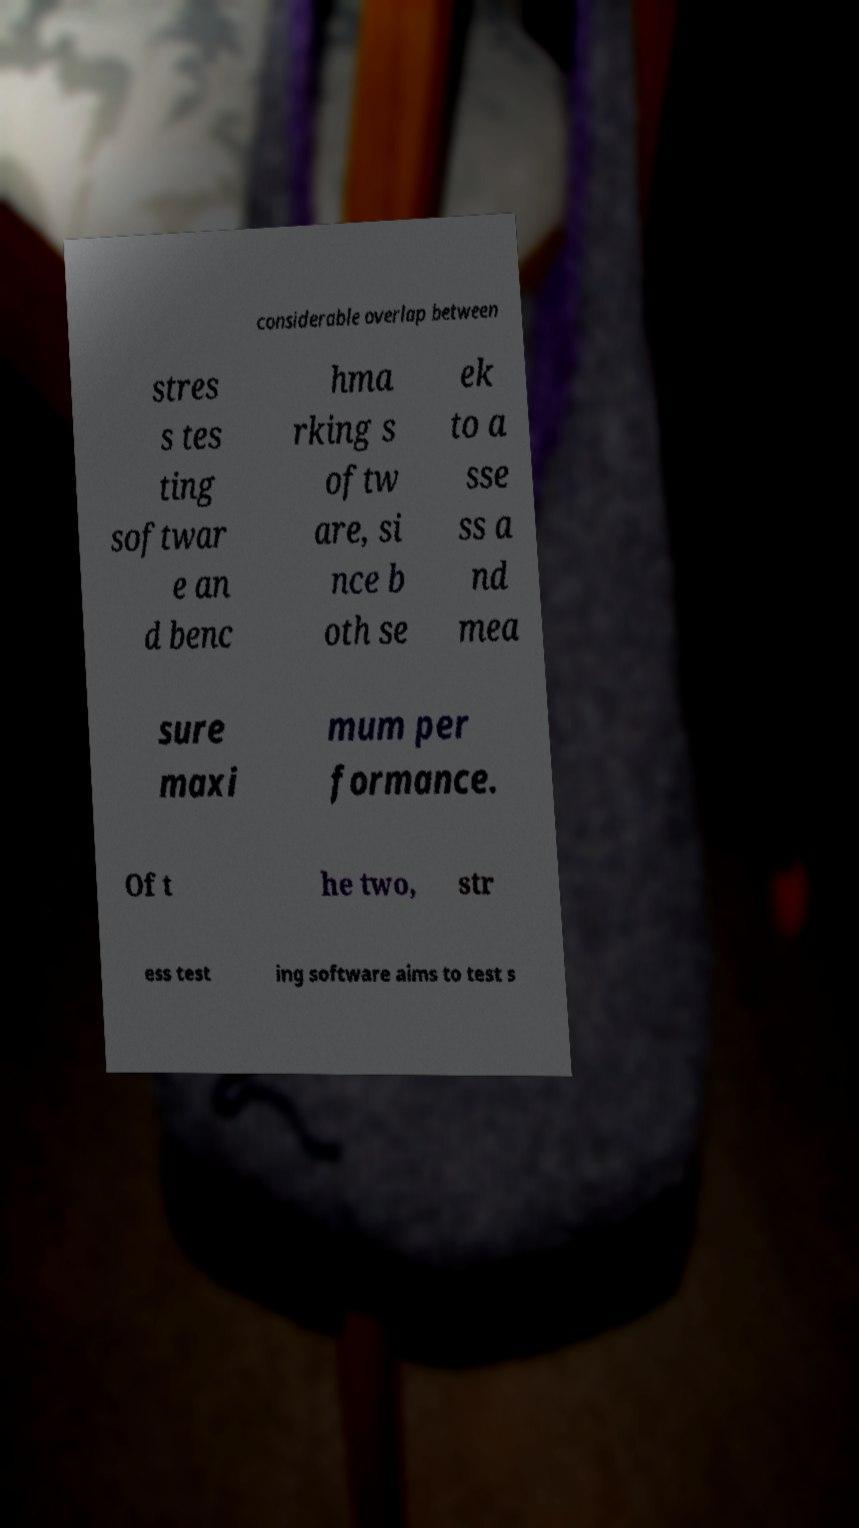What messages or text are displayed in this image? I need them in a readable, typed format. considerable overlap between stres s tes ting softwar e an d benc hma rking s oftw are, si nce b oth se ek to a sse ss a nd mea sure maxi mum per formance. Of t he two, str ess test ing software aims to test s 